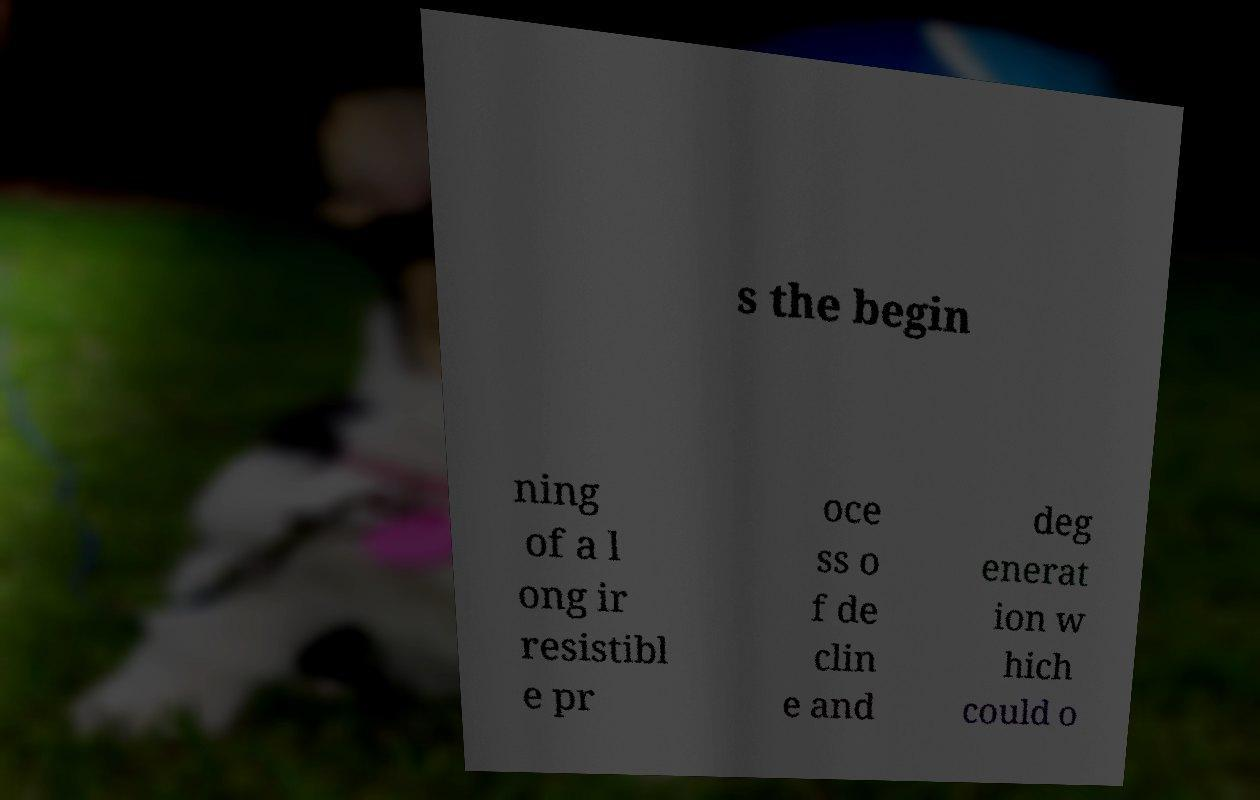Please read and relay the text visible in this image. What does it say? s the begin ning of a l ong ir resistibl e pr oce ss o f de clin e and deg enerat ion w hich could o 